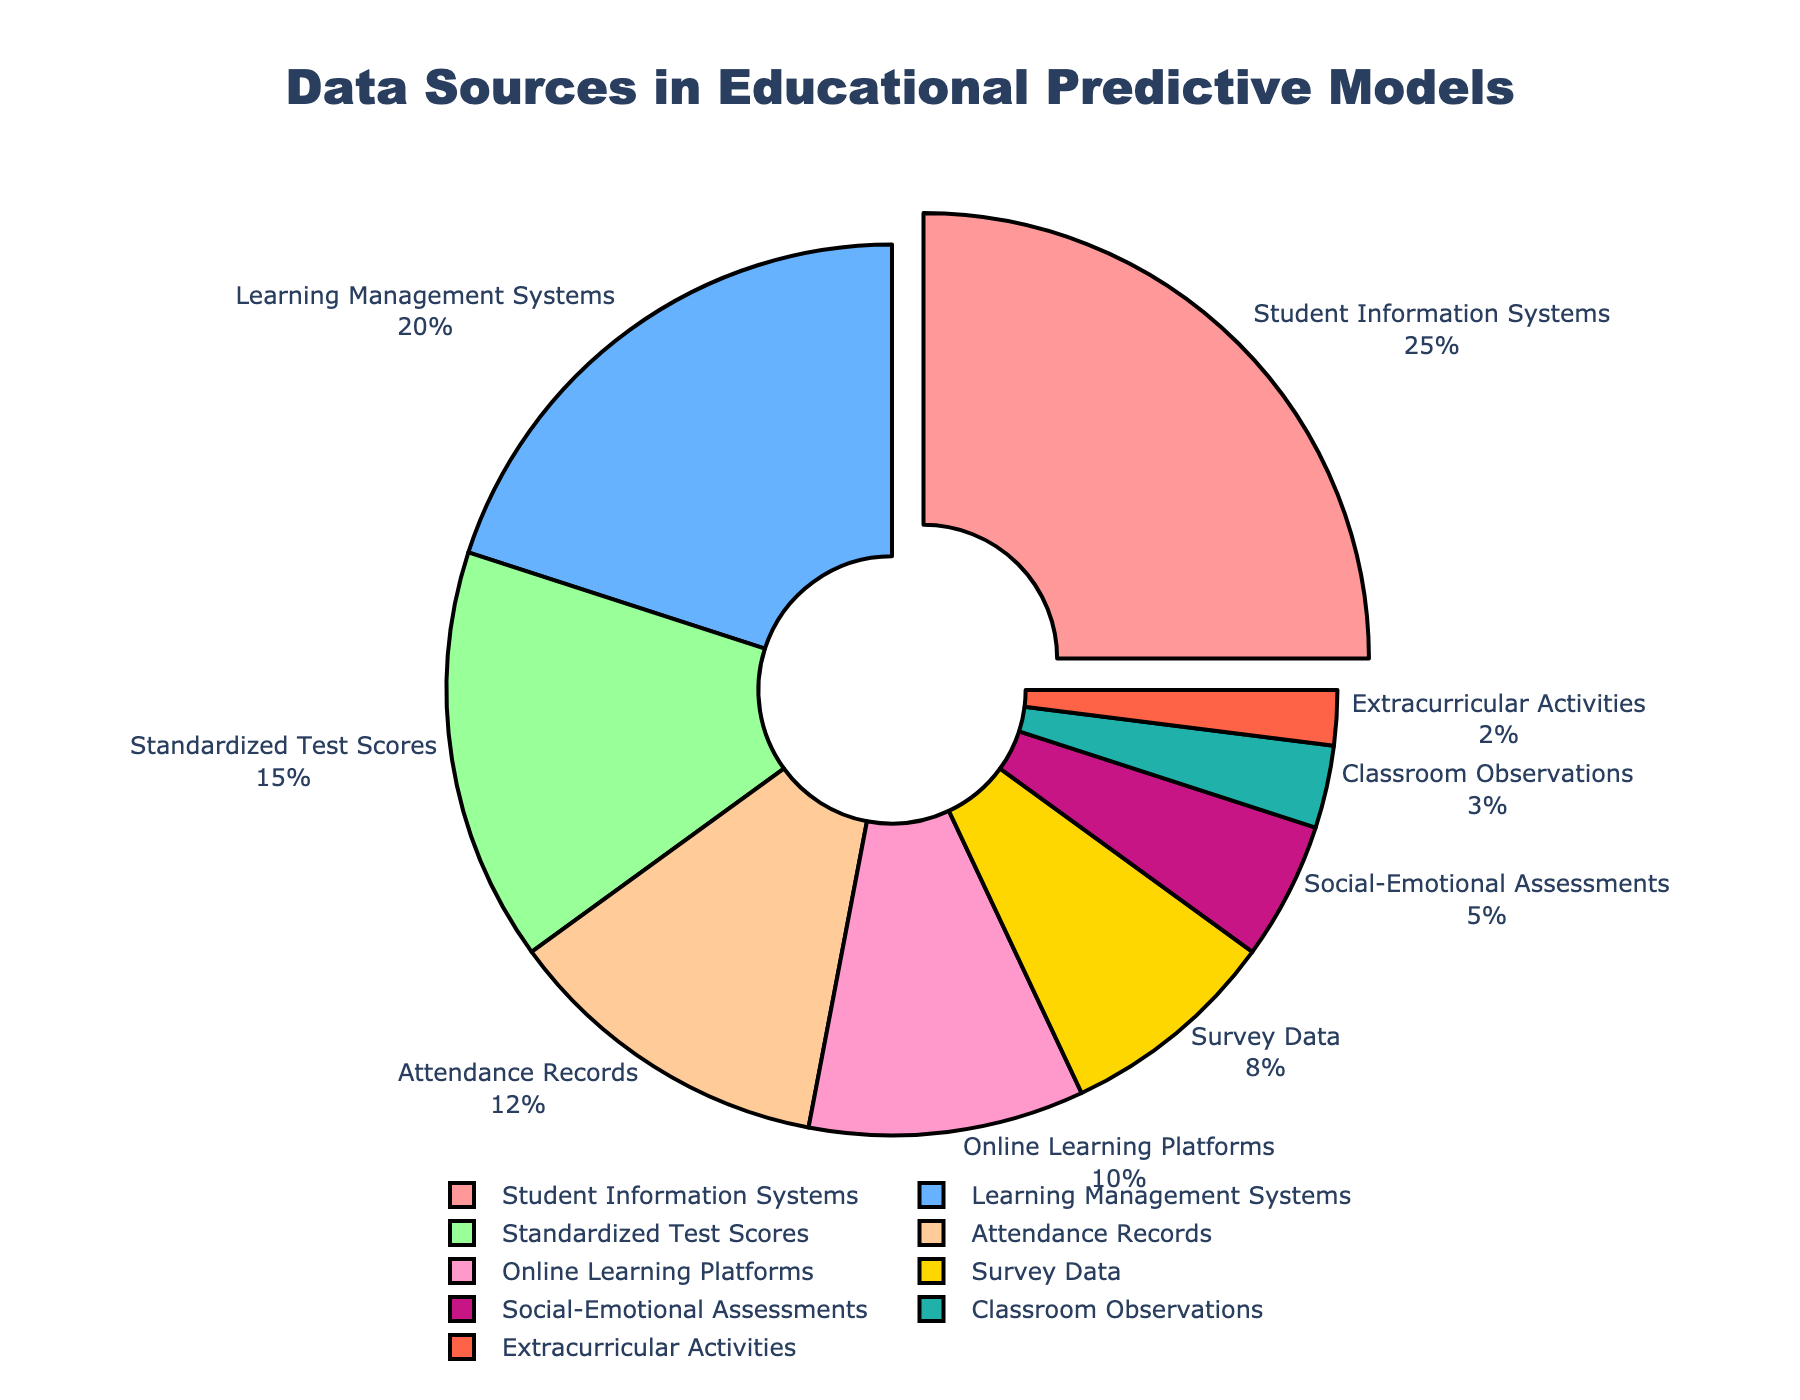What is the percentage contribution of Student Information Systems? From the pie chart, the percentage contribution of Student Information Systems is labeled as 25%.
Answer: 25% Which data source has the lowest percentage contribution? The pie chart shows that Extracurricular Activities have the smallest slice with a percentage contribution of 2%.
Answer: Extracurricular Activities How much more percentage does Student Information Systems contribute compared to Survey Data? Student Information Systems contribute 25%, and Survey Data contributes 8%. The difference is 25% - 8% = 17%.
Answer: 17% Which color represents Learning Management Systems? Observing the legend and corresponding pie slices, Learning Management Systems are represented by the color blue.
Answer: Blue What is the total percentage contribution of Online Learning Platforms and Standardized Test Scores combined? From the pie chart, Online Learning Platforms contribute 10%, and Standardized Test Scores contribute 15%. The combined contribution is 10% + 15% = 25%.
Answer: 25% Does Attendance Records have a higher contribution than Social-Emotional Assessments? Attendance Records contribute 12% while Social-Emotional Assessments contribute 5%. Since 12% > 5%, Attendance Records have a higher contribution.
Answer: Yes What percentage does Classroom Observations contribute, and how does it compare with the contribution of Social-Emotional Assessments? Classroom Observations contribute 3%, while Social-Emotional Assessments contribute 5%. Therefore, Classroom Observations contribute 2% less than Social-Emotional Assessments.
Answer: 3%, 2% less What is the summed contribution of Survey Data, Social-Emotional Assessments, and Extracurricular Activities? The pie chart shows that Survey Data contributes 8%, Social-Emotional Assessments contribute 5%, and Extracurricular Activities contribute 2%. The summed contribution is 8% + 5% + 2% = 15%.
Answer: 15% How does the proportion of Attendance Records compare with that of Standardized Test Scores? Attendance Records contribute 12%, while Standardized Test Scores contribute 15%. Since 12% < 15%, Attendance Records have a lower contribution.
Answer: Lower 